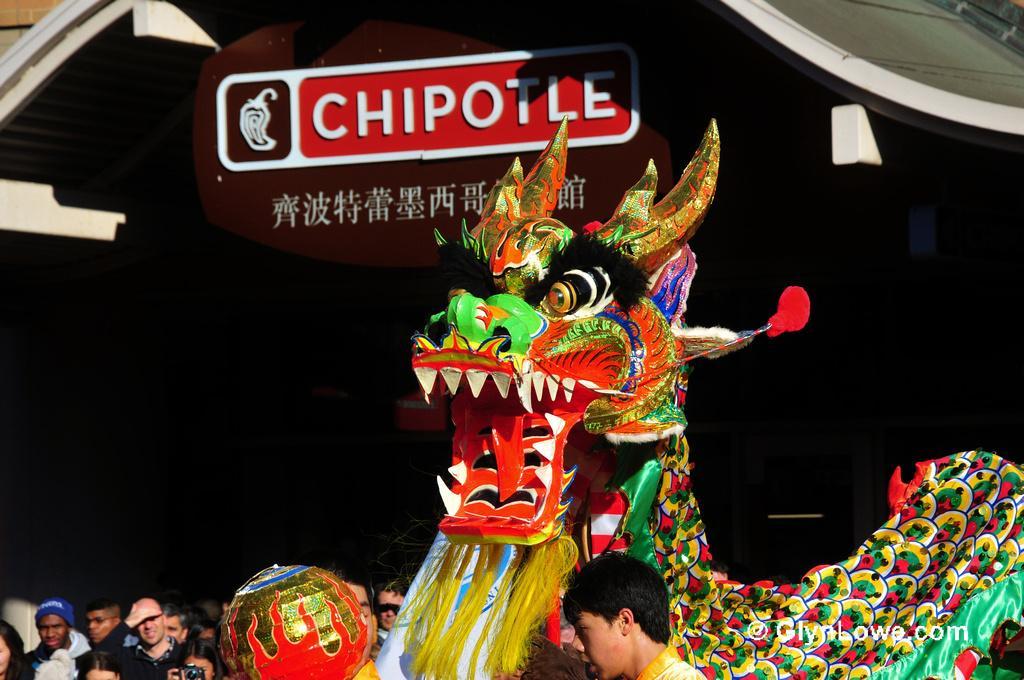Please provide a concise description of this image. In this image I can see few people. I can see a toy dragon and it is colorful. Background is in black color. I can see a brown board. 